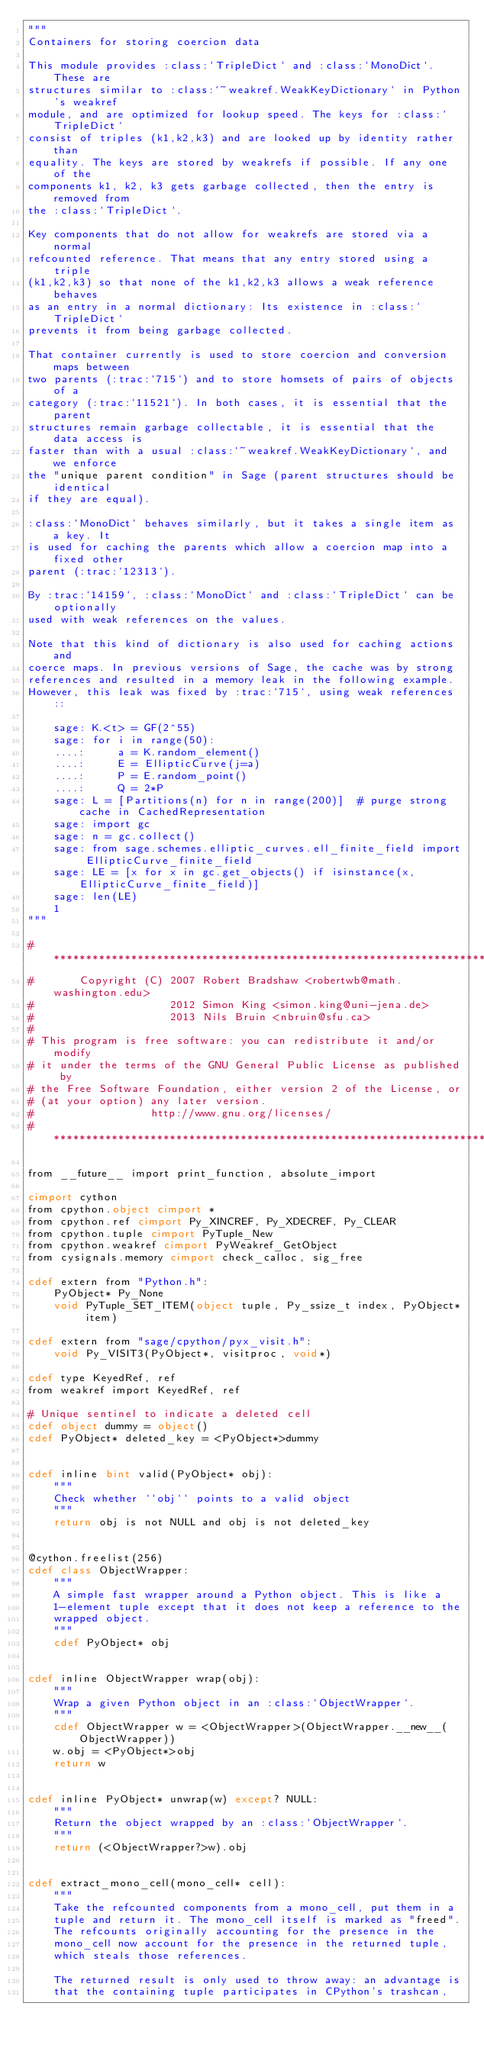Convert code to text. <code><loc_0><loc_0><loc_500><loc_500><_Cython_>"""
Containers for storing coercion data

This module provides :class:`TripleDict` and :class:`MonoDict`. These are
structures similar to :class:`~weakref.WeakKeyDictionary` in Python's weakref
module, and are optimized for lookup speed. The keys for :class:`TripleDict`
consist of triples (k1,k2,k3) and are looked up by identity rather than
equality. The keys are stored by weakrefs if possible. If any one of the
components k1, k2, k3 gets garbage collected, then the entry is removed from
the :class:`TripleDict`.

Key components that do not allow for weakrefs are stored via a normal
refcounted reference. That means that any entry stored using a triple
(k1,k2,k3) so that none of the k1,k2,k3 allows a weak reference behaves
as an entry in a normal dictionary: Its existence in :class:`TripleDict`
prevents it from being garbage collected.

That container currently is used to store coercion and conversion maps between
two parents (:trac:`715`) and to store homsets of pairs of objects of a
category (:trac:`11521`). In both cases, it is essential that the parent
structures remain garbage collectable, it is essential that the data access is
faster than with a usual :class:`~weakref.WeakKeyDictionary`, and we enforce
the "unique parent condition" in Sage (parent structures should be identical
if they are equal).

:class:`MonoDict` behaves similarly, but it takes a single item as a key. It
is used for caching the parents which allow a coercion map into a fixed other
parent (:trac:`12313`).

By :trac:`14159`, :class:`MonoDict` and :class:`TripleDict` can be optionally
used with weak references on the values.

Note that this kind of dictionary is also used for caching actions and
coerce maps. In previous versions of Sage, the cache was by strong
references and resulted in a memory leak in the following example.
However, this leak was fixed by :trac:`715`, using weak references::

    sage: K.<t> = GF(2^55)
    sage: for i in range(50):
    ....:     a = K.random_element()
    ....:     E = EllipticCurve(j=a)
    ....:     P = E.random_point()
    ....:     Q = 2*P
    sage: L = [Partitions(n) for n in range(200)]  # purge strong cache in CachedRepresentation
    sage: import gc
    sage: n = gc.collect()
    sage: from sage.schemes.elliptic_curves.ell_finite_field import EllipticCurve_finite_field
    sage: LE = [x for x in gc.get_objects() if isinstance(x, EllipticCurve_finite_field)]
    sage: len(LE)
    1
"""

#*****************************************************************************
#       Copyright (C) 2007 Robert Bradshaw <robertwb@math.washington.edu>
#                     2012 Simon King <simon.king@uni-jena.de>
#                     2013 Nils Bruin <nbruin@sfu.ca>
#
# This program is free software: you can redistribute it and/or modify
# it under the terms of the GNU General Public License as published by
# the Free Software Foundation, either version 2 of the License, or
# (at your option) any later version.
#                  http://www.gnu.org/licenses/
#*****************************************************************************

from __future__ import print_function, absolute_import

cimport cython
from cpython.object cimport *
from cpython.ref cimport Py_XINCREF, Py_XDECREF, Py_CLEAR
from cpython.tuple cimport PyTuple_New
from cpython.weakref cimport PyWeakref_GetObject
from cysignals.memory cimport check_calloc, sig_free

cdef extern from "Python.h":
    PyObject* Py_None
    void PyTuple_SET_ITEM(object tuple, Py_ssize_t index, PyObject* item)

cdef extern from "sage/cpython/pyx_visit.h":
    void Py_VISIT3(PyObject*, visitproc, void*)

cdef type KeyedRef, ref
from weakref import KeyedRef, ref

# Unique sentinel to indicate a deleted cell
cdef object dummy = object()
cdef PyObject* deleted_key = <PyObject*>dummy


cdef inline bint valid(PyObject* obj):
    """
    Check whether ``obj`` points to a valid object
    """
    return obj is not NULL and obj is not deleted_key


@cython.freelist(256)
cdef class ObjectWrapper:
    """
    A simple fast wrapper around a Python object. This is like a
    1-element tuple except that it does not keep a reference to the
    wrapped object.
    """
    cdef PyObject* obj


cdef inline ObjectWrapper wrap(obj):
    """
    Wrap a given Python object in an :class:`ObjectWrapper`.
    """
    cdef ObjectWrapper w = <ObjectWrapper>(ObjectWrapper.__new__(ObjectWrapper))
    w.obj = <PyObject*>obj
    return w


cdef inline PyObject* unwrap(w) except? NULL:
    """
    Return the object wrapped by an :class:`ObjectWrapper`.
    """
    return (<ObjectWrapper?>w).obj


cdef extract_mono_cell(mono_cell* cell):
    """
    Take the refcounted components from a mono_cell, put them in a
    tuple and return it. The mono_cell itself is marked as "freed".
    The refcounts originally accounting for the presence in the
    mono_cell now account for the presence in the returned tuple,
    which steals those references.

    The returned result is only used to throw away: an advantage is
    that the containing tuple participates in CPython's trashcan,</code> 